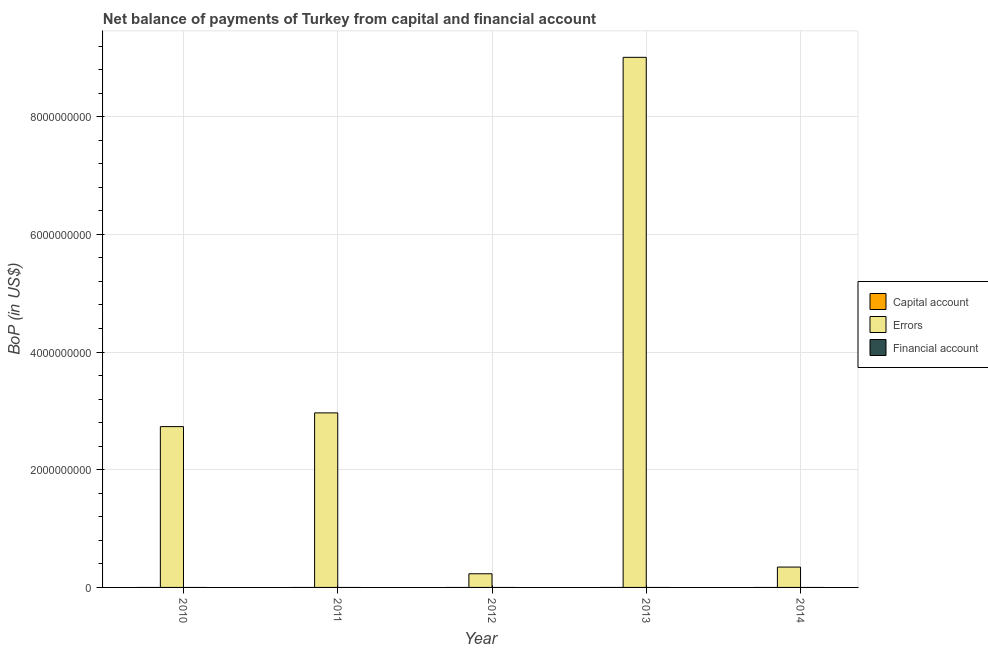Are the number of bars per tick equal to the number of legend labels?
Provide a succinct answer. No. What is the label of the 1st group of bars from the left?
Keep it short and to the point. 2010. In how many cases, is the number of bars for a given year not equal to the number of legend labels?
Your answer should be very brief. 5. What is the amount of net capital account in 2012?
Your answer should be compact. 0. Across all years, what is the maximum amount of errors?
Your response must be concise. 9.01e+09. Across all years, what is the minimum amount of financial account?
Give a very brief answer. 0. What is the total amount of financial account in the graph?
Your answer should be very brief. 0. What is the difference between the amount of errors in 2011 and that in 2014?
Your answer should be very brief. 2.62e+09. What is the difference between the amount of net capital account in 2010 and the amount of financial account in 2013?
Keep it short and to the point. 0. What is the average amount of errors per year?
Offer a terse response. 3.06e+09. What is the ratio of the amount of errors in 2010 to that in 2014?
Provide a succinct answer. 7.9. What is the difference between the highest and the second highest amount of errors?
Keep it short and to the point. 6.04e+09. What is the difference between the highest and the lowest amount of errors?
Give a very brief answer. 8.78e+09. In how many years, is the amount of errors greater than the average amount of errors taken over all years?
Make the answer very short. 1. Does the graph contain any zero values?
Your response must be concise. Yes. Does the graph contain grids?
Offer a terse response. Yes. Where does the legend appear in the graph?
Give a very brief answer. Center right. How many legend labels are there?
Your response must be concise. 3. What is the title of the graph?
Your answer should be compact. Net balance of payments of Turkey from capital and financial account. Does "Tertiary education" appear as one of the legend labels in the graph?
Keep it short and to the point. No. What is the label or title of the Y-axis?
Ensure brevity in your answer.  BoP (in US$). What is the BoP (in US$) of Errors in 2010?
Your response must be concise. 2.73e+09. What is the BoP (in US$) of Errors in 2011?
Your answer should be compact. 2.97e+09. What is the BoP (in US$) of Capital account in 2012?
Offer a very short reply. 0. What is the BoP (in US$) of Errors in 2012?
Provide a short and direct response. 2.32e+08. What is the BoP (in US$) in Financial account in 2012?
Your response must be concise. 0. What is the BoP (in US$) of Errors in 2013?
Offer a very short reply. 9.01e+09. What is the BoP (in US$) in Errors in 2014?
Your response must be concise. 3.46e+08. What is the BoP (in US$) of Financial account in 2014?
Give a very brief answer. 0. Across all years, what is the maximum BoP (in US$) in Errors?
Ensure brevity in your answer.  9.01e+09. Across all years, what is the minimum BoP (in US$) of Errors?
Give a very brief answer. 2.32e+08. What is the total BoP (in US$) in Errors in the graph?
Provide a succinct answer. 1.53e+1. What is the difference between the BoP (in US$) of Errors in 2010 and that in 2011?
Your response must be concise. -2.33e+08. What is the difference between the BoP (in US$) of Errors in 2010 and that in 2012?
Your answer should be very brief. 2.50e+09. What is the difference between the BoP (in US$) of Errors in 2010 and that in 2013?
Your response must be concise. -6.28e+09. What is the difference between the BoP (in US$) in Errors in 2010 and that in 2014?
Ensure brevity in your answer.  2.39e+09. What is the difference between the BoP (in US$) of Errors in 2011 and that in 2012?
Your response must be concise. 2.73e+09. What is the difference between the BoP (in US$) in Errors in 2011 and that in 2013?
Ensure brevity in your answer.  -6.04e+09. What is the difference between the BoP (in US$) of Errors in 2011 and that in 2014?
Your answer should be compact. 2.62e+09. What is the difference between the BoP (in US$) in Errors in 2012 and that in 2013?
Provide a succinct answer. -8.78e+09. What is the difference between the BoP (in US$) in Errors in 2012 and that in 2014?
Your answer should be very brief. -1.14e+08. What is the difference between the BoP (in US$) in Errors in 2013 and that in 2014?
Provide a short and direct response. 8.66e+09. What is the average BoP (in US$) of Errors per year?
Offer a very short reply. 3.06e+09. What is the average BoP (in US$) in Financial account per year?
Keep it short and to the point. 0. What is the ratio of the BoP (in US$) in Errors in 2010 to that in 2011?
Keep it short and to the point. 0.92. What is the ratio of the BoP (in US$) of Errors in 2010 to that in 2012?
Give a very brief answer. 11.78. What is the ratio of the BoP (in US$) in Errors in 2010 to that in 2013?
Make the answer very short. 0.3. What is the ratio of the BoP (in US$) of Errors in 2010 to that in 2014?
Your answer should be very brief. 7.9. What is the ratio of the BoP (in US$) of Errors in 2011 to that in 2012?
Offer a terse response. 12.78. What is the ratio of the BoP (in US$) in Errors in 2011 to that in 2013?
Ensure brevity in your answer.  0.33. What is the ratio of the BoP (in US$) of Errors in 2011 to that in 2014?
Provide a short and direct response. 8.57. What is the ratio of the BoP (in US$) in Errors in 2012 to that in 2013?
Provide a succinct answer. 0.03. What is the ratio of the BoP (in US$) of Errors in 2012 to that in 2014?
Make the answer very short. 0.67. What is the ratio of the BoP (in US$) of Errors in 2013 to that in 2014?
Offer a terse response. 26.03. What is the difference between the highest and the second highest BoP (in US$) of Errors?
Keep it short and to the point. 6.04e+09. What is the difference between the highest and the lowest BoP (in US$) of Errors?
Your answer should be very brief. 8.78e+09. 